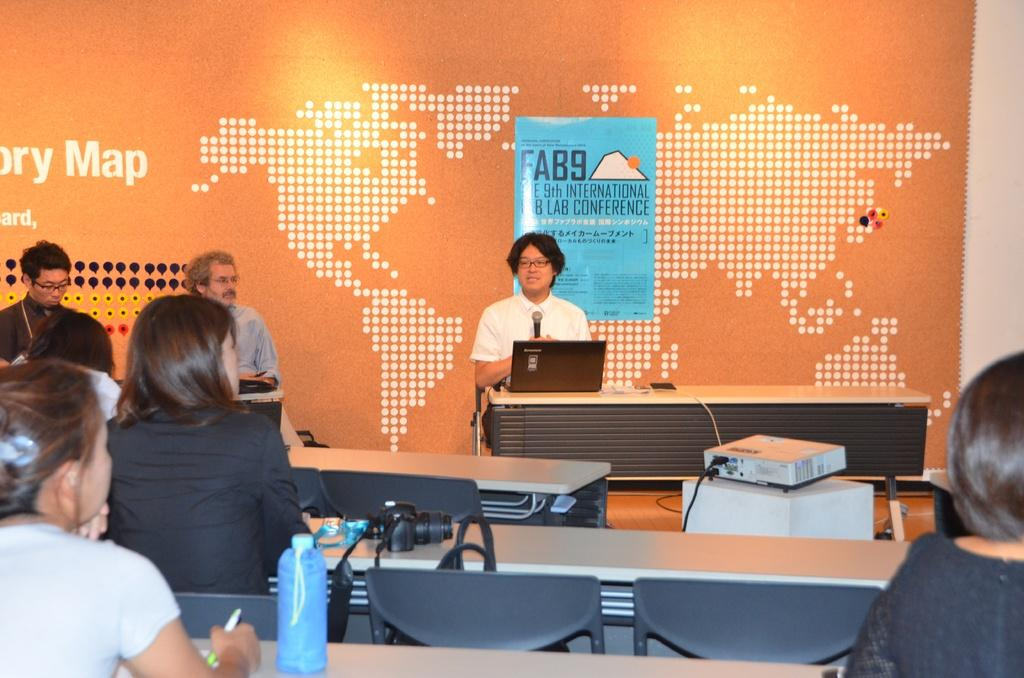What are the people in the image doing? The people in the image are sitting on chairs. Can you describe what one of the people is holding? One person is holding a microphone. What electronic device is present on the table in the image? There is a laptop on a table in the image. What type of throne is the person sitting on in the image? There is no throne present in the image; the people are sitting on chairs. How many feet are visible in the image? The provided facts do not mention any feet, so it is impossible to determine how many are visible in the image. 